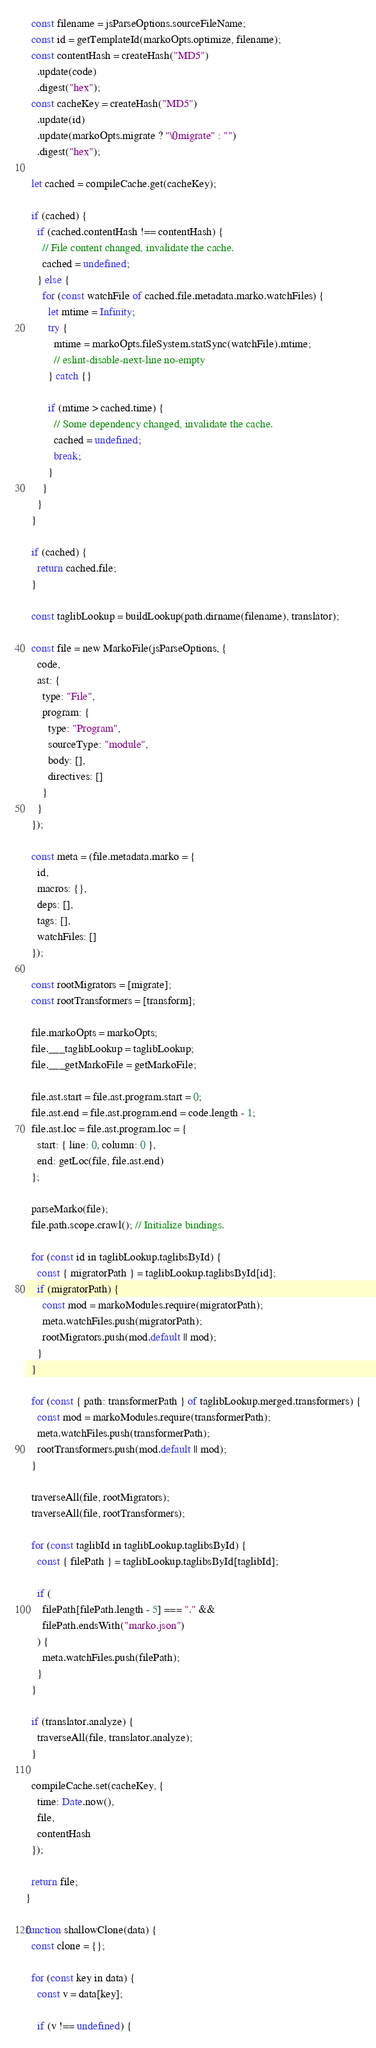Convert code to text. <code><loc_0><loc_0><loc_500><loc_500><_JavaScript_>  const filename = jsParseOptions.sourceFileName;
  const id = getTemplateId(markoOpts.optimize, filename);
  const contentHash = createHash("MD5")
    .update(code)
    .digest("hex");
  const cacheKey = createHash("MD5")
    .update(id)
    .update(markoOpts.migrate ? "\0migrate" : "")
    .digest("hex");

  let cached = compileCache.get(cacheKey);

  if (cached) {
    if (cached.contentHash !== contentHash) {
      // File content changed, invalidate the cache.
      cached = undefined;
    } else {
      for (const watchFile of cached.file.metadata.marko.watchFiles) {
        let mtime = Infinity;
        try {
          mtime = markoOpts.fileSystem.statSync(watchFile).mtime;
          // eslint-disable-next-line no-empty
        } catch {}

        if (mtime > cached.time) {
          // Some dependency changed, invalidate the cache.
          cached = undefined;
          break;
        }
      }
    }
  }

  if (cached) {
    return cached.file;
  }

  const taglibLookup = buildLookup(path.dirname(filename), translator);

  const file = new MarkoFile(jsParseOptions, {
    code,
    ast: {
      type: "File",
      program: {
        type: "Program",
        sourceType: "module",
        body: [],
        directives: []
      }
    }
  });

  const meta = (file.metadata.marko = {
    id,
    macros: {},
    deps: [],
    tags: [],
    watchFiles: []
  });

  const rootMigrators = [migrate];
  const rootTransformers = [transform];

  file.markoOpts = markoOpts;
  file.___taglibLookup = taglibLookup;
  file.___getMarkoFile = getMarkoFile;

  file.ast.start = file.ast.program.start = 0;
  file.ast.end = file.ast.program.end = code.length - 1;
  file.ast.loc = file.ast.program.loc = {
    start: { line: 0, column: 0 },
    end: getLoc(file, file.ast.end)
  };

  parseMarko(file);
  file.path.scope.crawl(); // Initialize bindings.

  for (const id in taglibLookup.taglibsById) {
    const { migratorPath } = taglibLookup.taglibsById[id];
    if (migratorPath) {
      const mod = markoModules.require(migratorPath);
      meta.watchFiles.push(migratorPath);
      rootMigrators.push(mod.default || mod);
    }
  }

  for (const { path: transformerPath } of taglibLookup.merged.transformers) {
    const mod = markoModules.require(transformerPath);
    meta.watchFiles.push(transformerPath);
    rootTransformers.push(mod.default || mod);
  }

  traverseAll(file, rootMigrators);
  traverseAll(file, rootTransformers);

  for (const taglibId in taglibLookup.taglibsById) {
    const { filePath } = taglibLookup.taglibsById[taglibId];

    if (
      filePath[filePath.length - 5] === "." &&
      filePath.endsWith("marko.json")
    ) {
      meta.watchFiles.push(filePath);
    }
  }

  if (translator.analyze) {
    traverseAll(file, translator.analyze);
  }

  compileCache.set(cacheKey, {
    time: Date.now(),
    file,
    contentHash
  });

  return file;
}

function shallowClone(data) {
  const clone = {};

  for (const key in data) {
    const v = data[key];

    if (v !== undefined) {</code> 